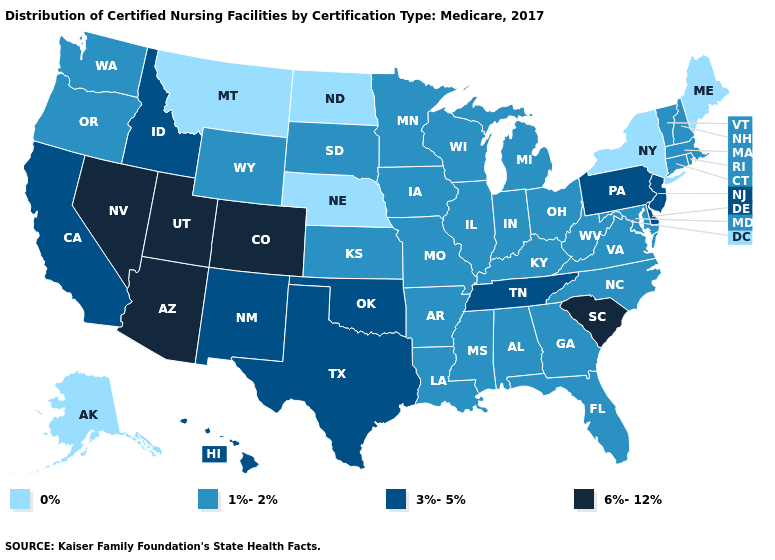Which states have the lowest value in the MidWest?
Quick response, please. Nebraska, North Dakota. Is the legend a continuous bar?
Keep it brief. No. Which states have the highest value in the USA?
Be succinct. Arizona, Colorado, Nevada, South Carolina, Utah. What is the value of Maine?
Answer briefly. 0%. Does Connecticut have a higher value than New York?
Quick response, please. Yes. Name the states that have a value in the range 1%-2%?
Concise answer only. Alabama, Arkansas, Connecticut, Florida, Georgia, Illinois, Indiana, Iowa, Kansas, Kentucky, Louisiana, Maryland, Massachusetts, Michigan, Minnesota, Mississippi, Missouri, New Hampshire, North Carolina, Ohio, Oregon, Rhode Island, South Dakota, Vermont, Virginia, Washington, West Virginia, Wisconsin, Wyoming. What is the value of North Carolina?
Concise answer only. 1%-2%. Name the states that have a value in the range 0%?
Quick response, please. Alaska, Maine, Montana, Nebraska, New York, North Dakota. What is the value of Indiana?
Quick response, please. 1%-2%. Among the states that border Oklahoma , does Kansas have the lowest value?
Concise answer only. Yes. Does the first symbol in the legend represent the smallest category?
Concise answer only. Yes. Does Michigan have a higher value than New York?
Quick response, please. Yes. Name the states that have a value in the range 1%-2%?
Give a very brief answer. Alabama, Arkansas, Connecticut, Florida, Georgia, Illinois, Indiana, Iowa, Kansas, Kentucky, Louisiana, Maryland, Massachusetts, Michigan, Minnesota, Mississippi, Missouri, New Hampshire, North Carolina, Ohio, Oregon, Rhode Island, South Dakota, Vermont, Virginia, Washington, West Virginia, Wisconsin, Wyoming. What is the value of Alabama?
Write a very short answer. 1%-2%. 